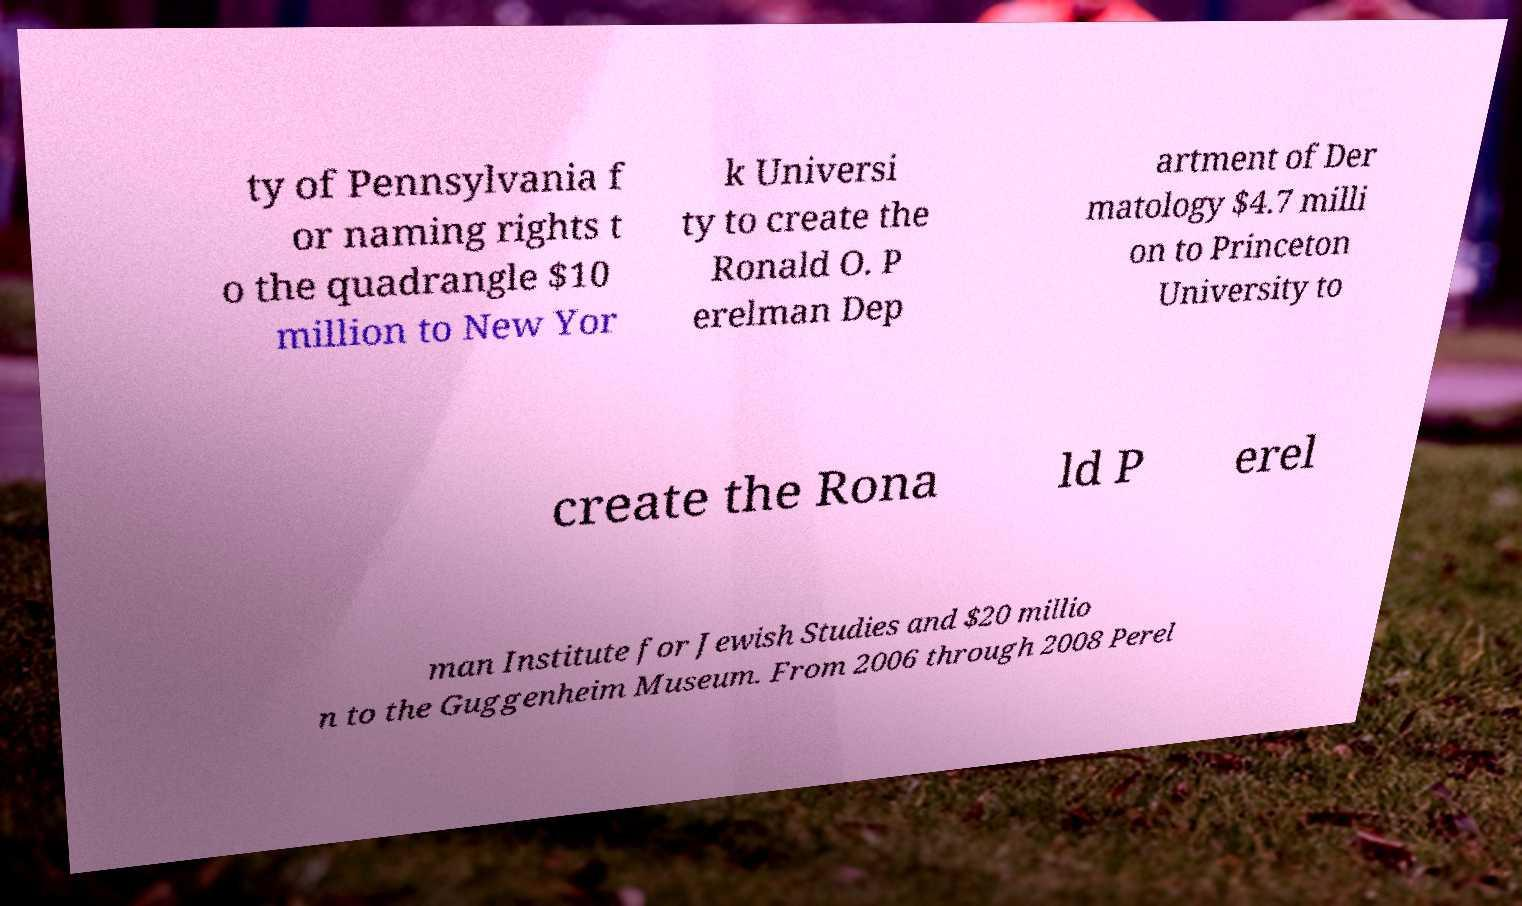Can you accurately transcribe the text from the provided image for me? ty of Pennsylvania f or naming rights t o the quadrangle $10 million to New Yor k Universi ty to create the Ronald O. P erelman Dep artment of Der matology $4.7 milli on to Princeton University to create the Rona ld P erel man Institute for Jewish Studies and $20 millio n to the Guggenheim Museum. From 2006 through 2008 Perel 